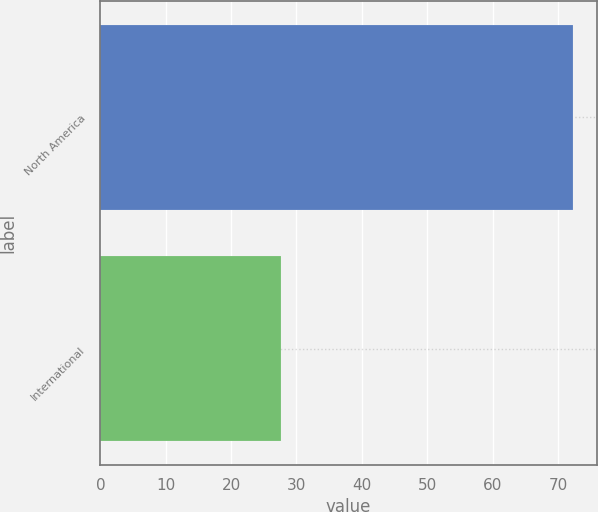Convert chart. <chart><loc_0><loc_0><loc_500><loc_500><bar_chart><fcel>North America<fcel>International<nl><fcel>72.3<fcel>27.7<nl></chart> 